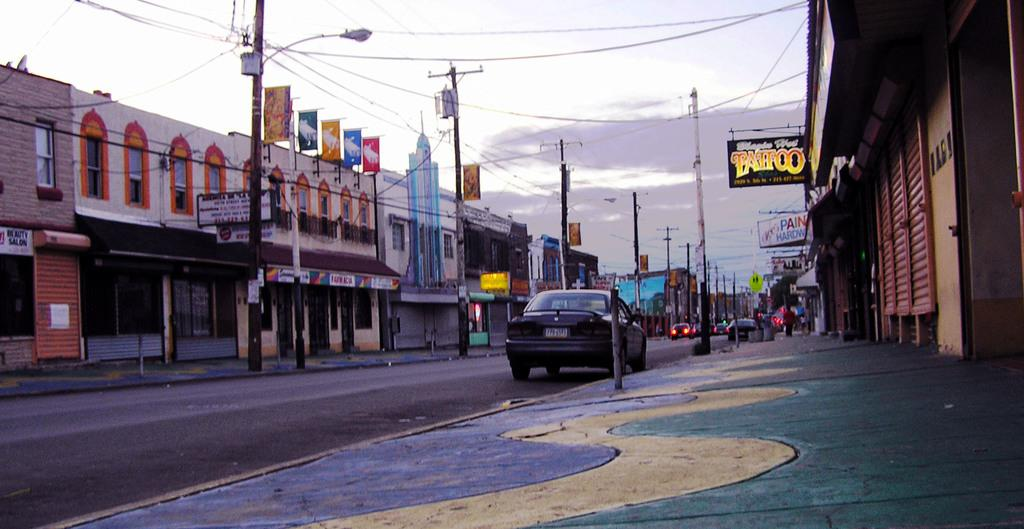What is happening on the road in the image? There are vehicles moving on the road in the image. What can be seen on either side of the road? There are buildings on both sides of the road. What else is visible in the image besides the vehicles and buildings? There are poles visible in the image. Are there any additional features or objects present in the image? Yes, banners are present in the image. What type of can is being used to solve arithmetic problems in the image? There is no can or arithmetic problem present in the image. What is the name of the person depicted on the banner in the image? There is no person's name mentioned on the banner in the image. 